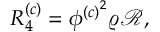<formula> <loc_0><loc_0><loc_500><loc_500>\begin{array} { r } { R _ { 4 } ^ { \left ( c \right ) } = \phi ^ { \left ( c \right ) ^ { 2 } } \varrho \mathcal { R } , } \end{array}</formula> 